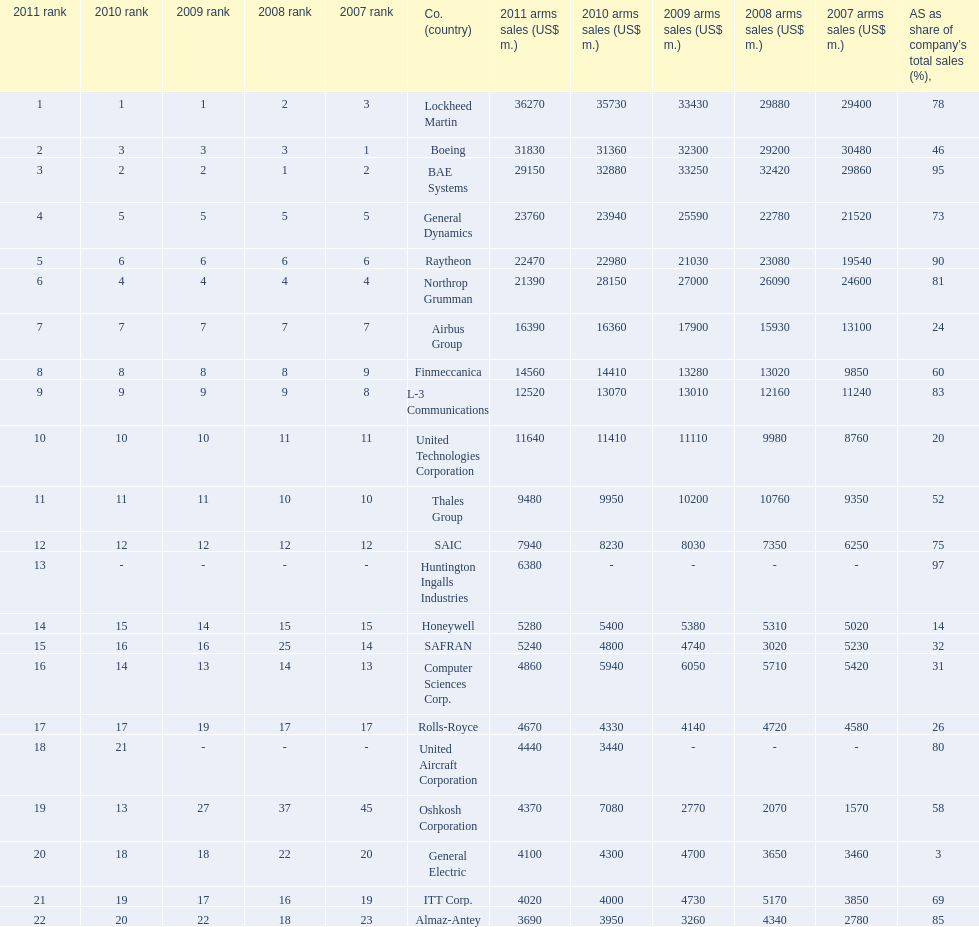Which company had the highest 2009 arms sales? Lockheed Martin. 